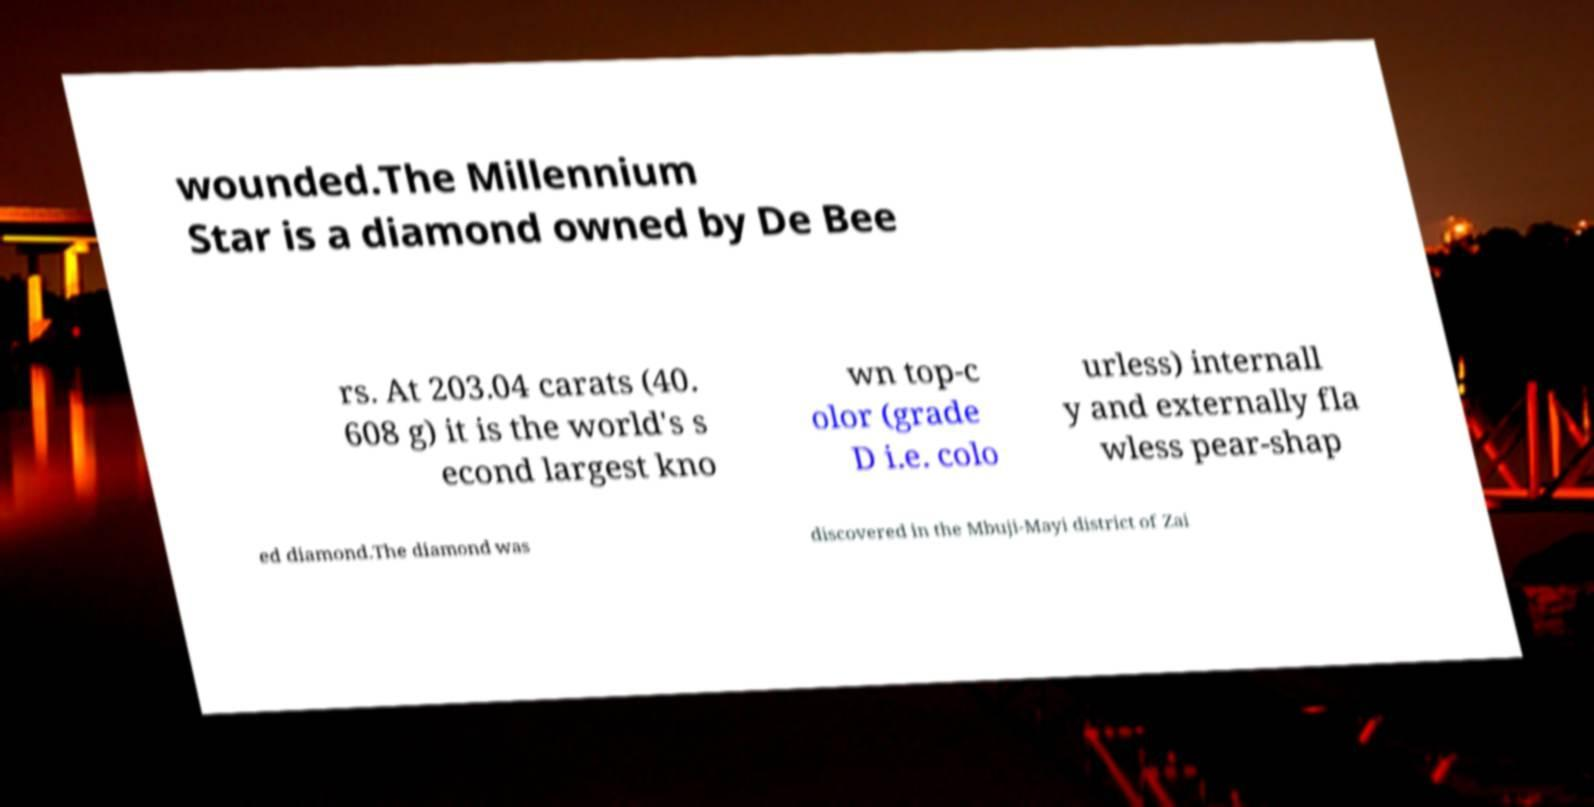What messages or text are displayed in this image? I need them in a readable, typed format. wounded.The Millennium Star is a diamond owned by De Bee rs. At 203.04 carats (40. 608 g) it is the world's s econd largest kno wn top-c olor (grade D i.e. colo urless) internall y and externally fla wless pear-shap ed diamond.The diamond was discovered in the Mbuji-Mayi district of Zai 